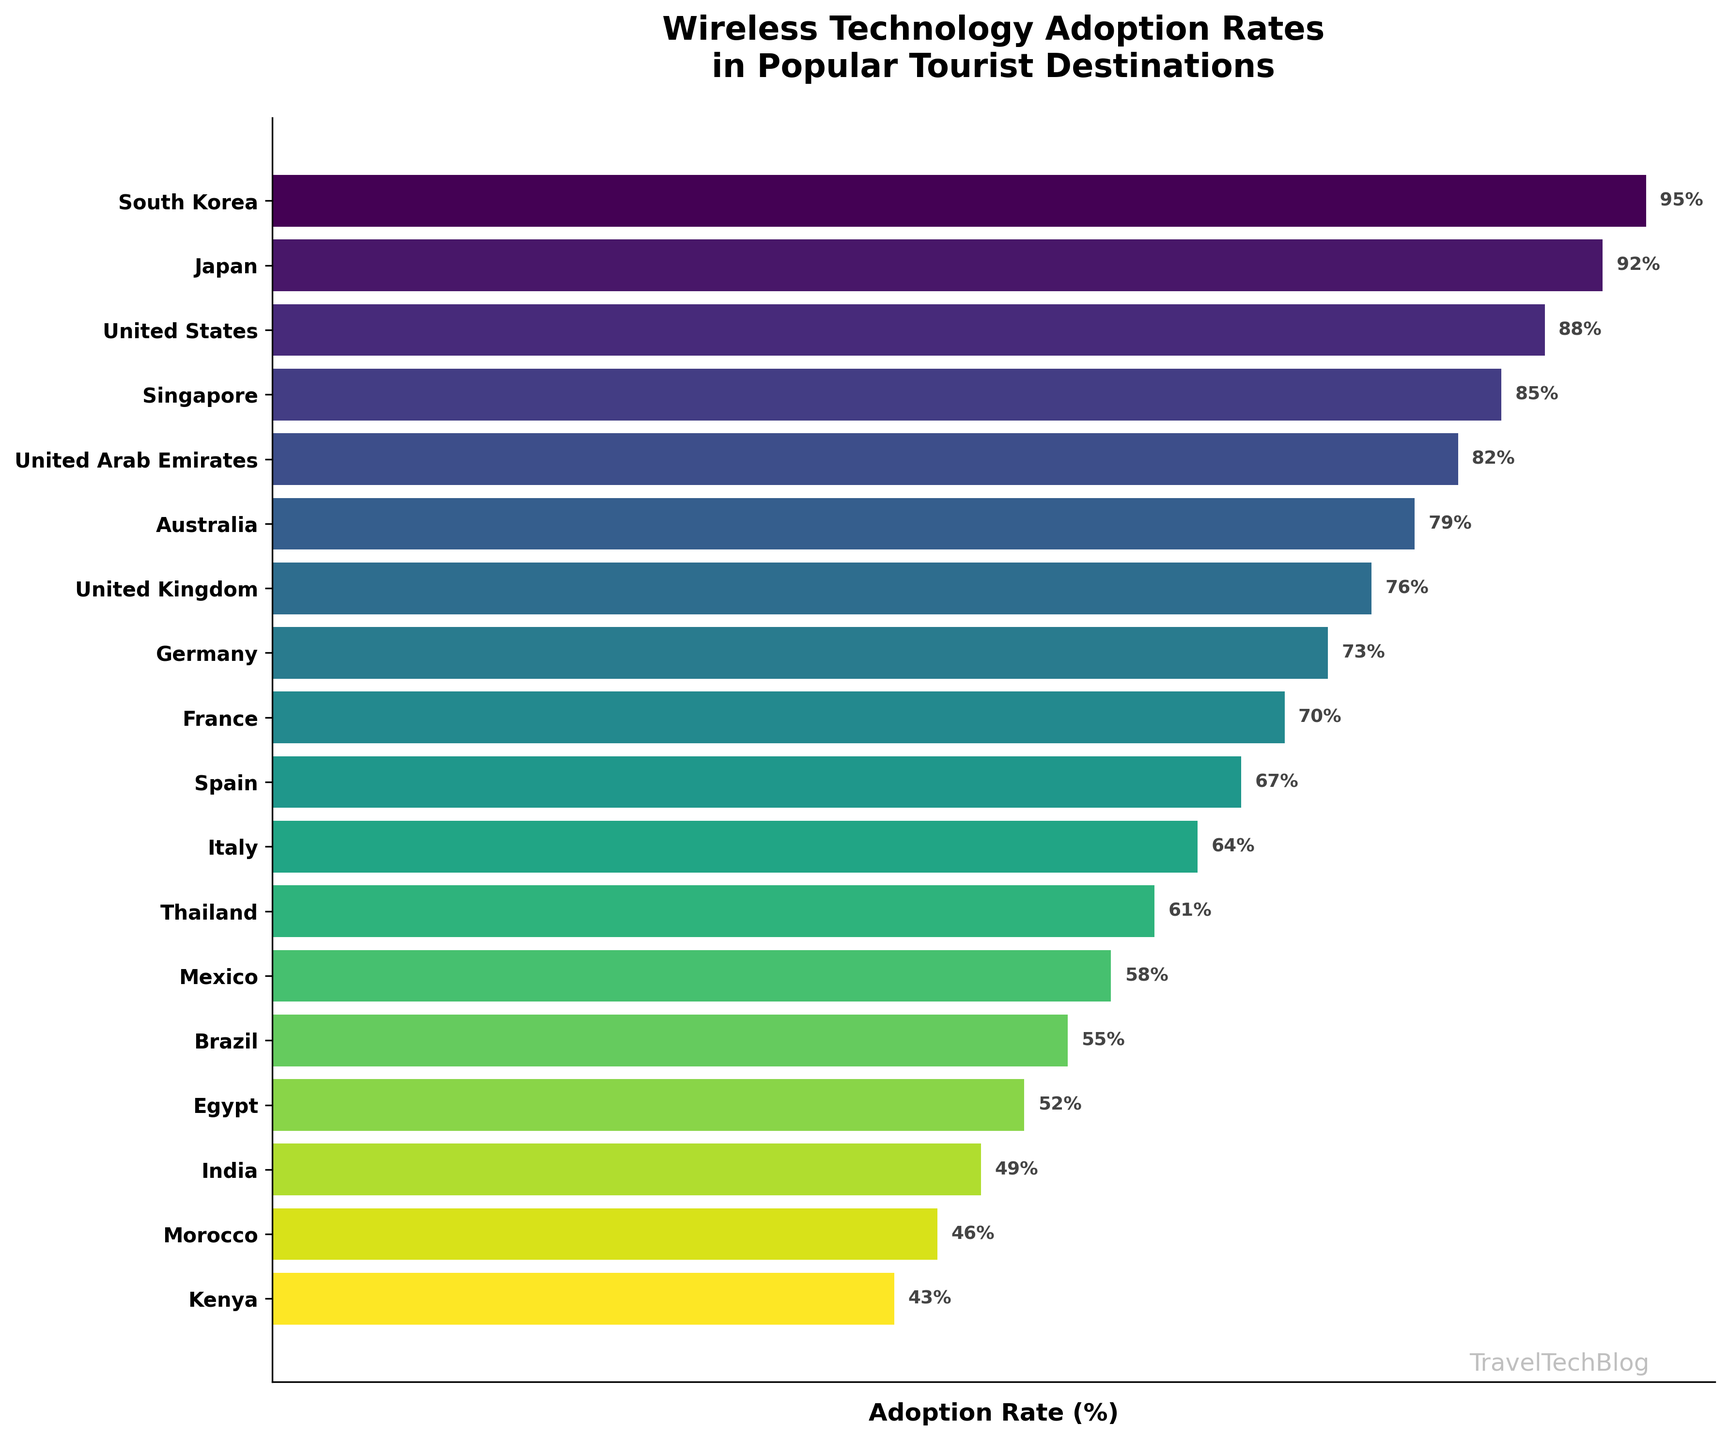What's the title of the funnel chart? The title of the chart is usually found at the top and summarizes the main topic of the chart.
Answer: Wireless Technology Adoption Rates in Popular Tourist Destinations How many destinations are included in the funnel chart? Count the number of unique destination names listed on the y-axis.
Answer: 18 Which destination has the highest adoption rate? Identify the topmost bar, which corresponds to the highest value.
Answer: South Korea Which destination has the lowest adoption rate? Identify the bottommost bar, which corresponds to the lowest value.
Answer: Kenya What is the adoption rate for Japan? Find Japan on the y-axis and read the corresponding percentage label on the bar.
Answer: 92% What is the difference in adoption rates between the United States and the United Kingdom? Identify the rates for both destinations, then calculate the difference (88% - 76%).
Answer: 12% How many destinations have an adoption rate above 80%? Count all destinations with a percentage label greater than 80%.
Answer: 5 What is the average adoption rate for the top five destinations? Sum the adoption rates of the top five destinations (95 + 92 + 88 + 85 + 82) and divide by 5.
Answer: 88.4% Which destination has an adoption rate closest to 60%? Identify the destinations around the 60% mark and determine the closest value.
Answer: Thailand How does the adoption rate of Italy compare to that of France? Identify the rates for both Italy and France, then compare them (64% vs. 70%).
Answer: Italy's rate is lower than France's 